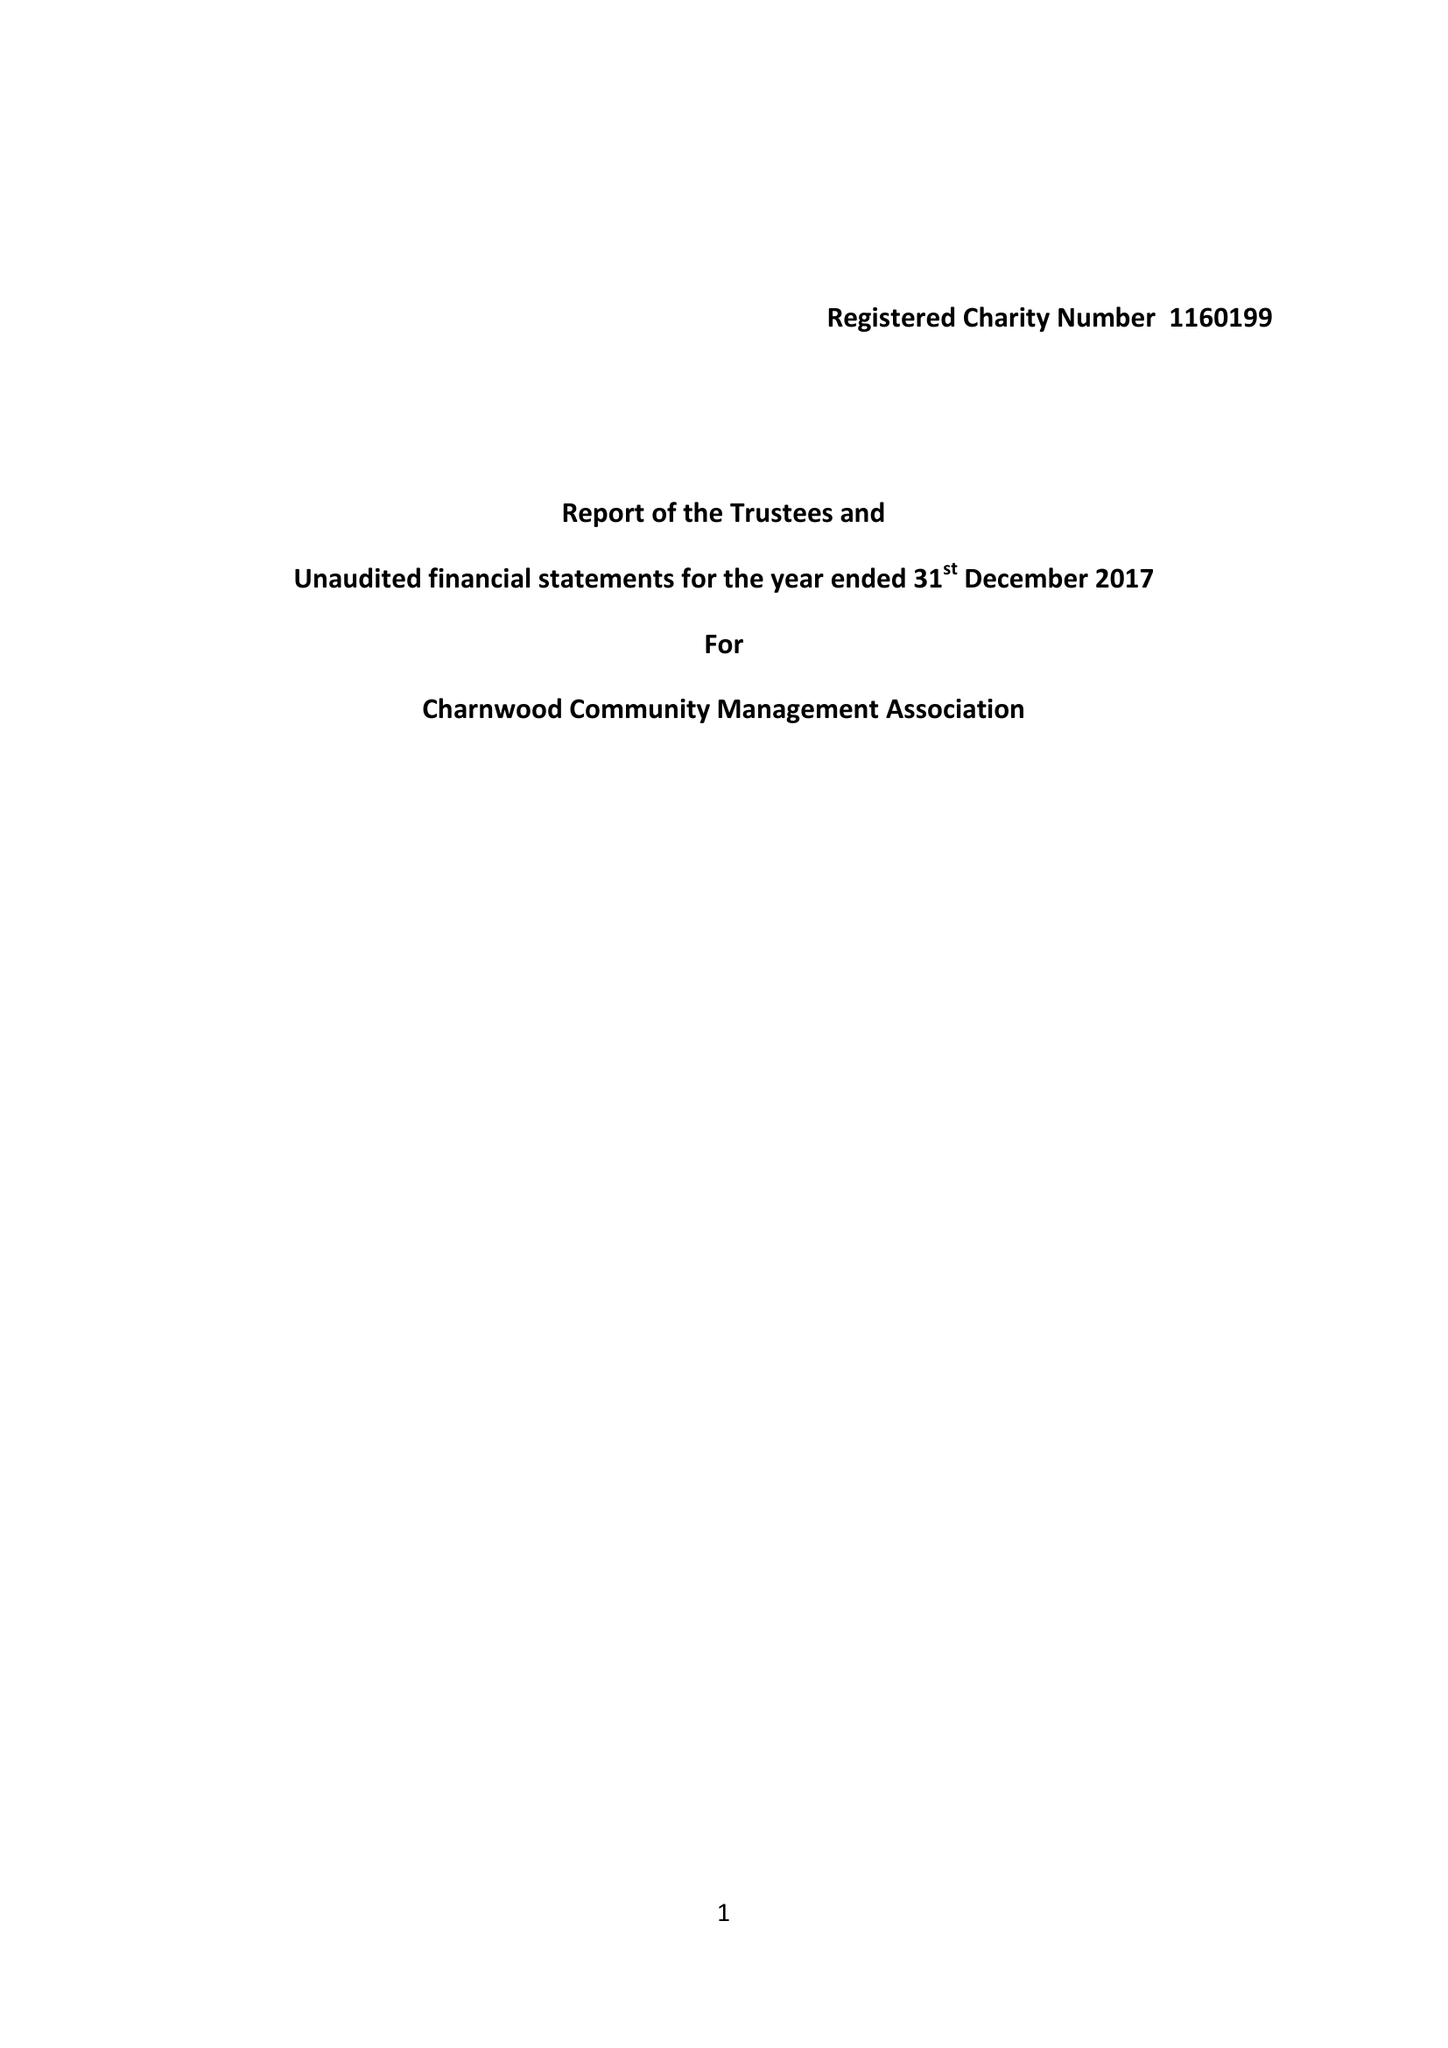What is the value for the report_date?
Answer the question using a single word or phrase. 2017-12-31 